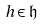Convert formula to latex. <formula><loc_0><loc_0><loc_500><loc_500>h \in { \mathfrak { h } }</formula> 